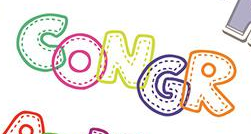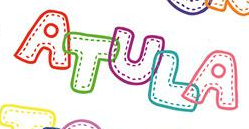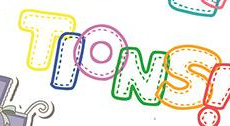Identify the words shown in these images in order, separated by a semicolon. CONGR; ATULA; TIONS 